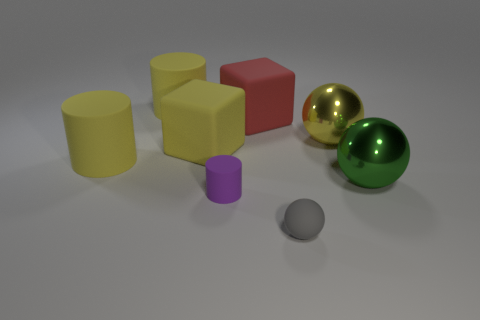Subtract all yellow rubber cylinders. How many cylinders are left? 1 Add 2 purple cylinders. How many objects exist? 10 Subtract all green balls. How many balls are left? 2 Subtract 2 cylinders. How many cylinders are left? 1 Subtract all green cubes. Subtract all purple cylinders. How many cubes are left? 2 Subtract all purple cylinders. How many brown blocks are left? 0 Subtract all big yellow cylinders. Subtract all large yellow spheres. How many objects are left? 5 Add 7 green spheres. How many green spheres are left? 8 Add 4 yellow spheres. How many yellow spheres exist? 5 Subtract 0 purple cubes. How many objects are left? 8 